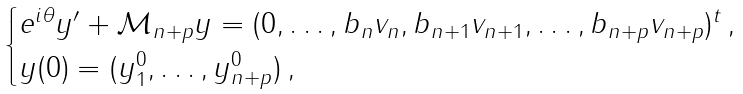<formula> <loc_0><loc_0><loc_500><loc_500>\begin{cases} e ^ { i \theta } y ^ { \prime } + \mathcal { M } _ { n + p } y = ( 0 , \dots , b _ { n } v _ { n } , b _ { n + 1 } v _ { n + 1 } , \dots , b _ { n + p } v _ { n + p } ) ^ { t } \, , \\ y ( 0 ) = ( y _ { 1 } ^ { 0 } , \dots , y _ { n + p } ^ { 0 } ) \, , \end{cases}</formula> 